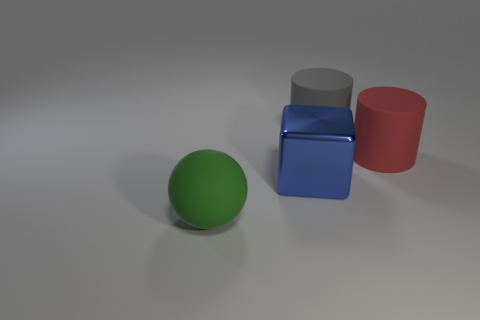Add 1 gray rubber objects. How many objects exist? 5 Subtract all balls. How many objects are left? 3 Subtract 1 cylinders. How many cylinders are left? 1 Subtract all yellow cylinders. Subtract all red spheres. How many cylinders are left? 2 Subtract all purple cylinders. How many red blocks are left? 0 Subtract all big red things. Subtract all big red matte objects. How many objects are left? 2 Add 4 gray cylinders. How many gray cylinders are left? 5 Add 3 green things. How many green things exist? 4 Subtract 1 red cylinders. How many objects are left? 3 